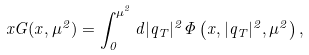<formula> <loc_0><loc_0><loc_500><loc_500>x G ( x , \mu ^ { 2 } ) = \int _ { 0 } ^ { \mu ^ { 2 } } d | { q } _ { T } | ^ { 2 } \Phi \left ( x , | { q } _ { T } | ^ { 2 } , \mu ^ { 2 } \right ) ,</formula> 